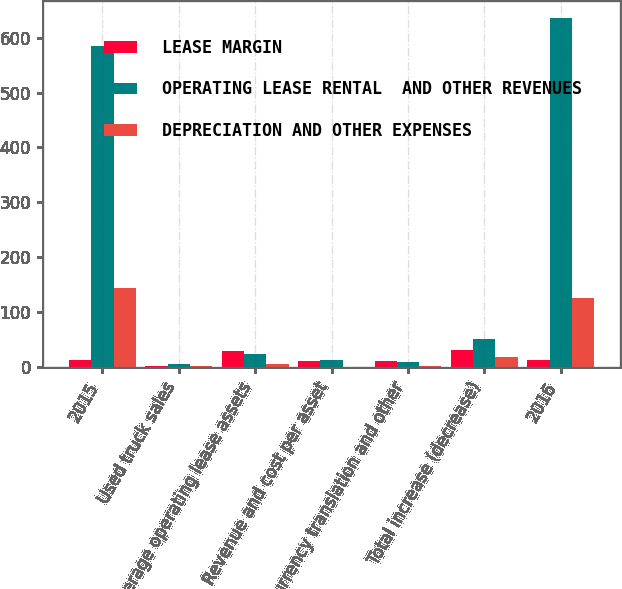Convert chart to OTSL. <chart><loc_0><loc_0><loc_500><loc_500><stacked_bar_chart><ecel><fcel>2015<fcel>Used truck sales<fcel>Average operating lease assets<fcel>Revenue and cost per asset<fcel>Currency translation and other<fcel>Total increase (decrease)<fcel>2016<nl><fcel>LEASE MARGIN<fcel>12.5<fcel>3.2<fcel>29.2<fcel>11.8<fcel>12.2<fcel>32<fcel>12.5<nl><fcel>OPERATING LEASE RENTAL  AND OTHER REVENUES<fcel>583.7<fcel>5.2<fcel>24<fcel>12.5<fcel>9.4<fcel>51.5<fcel>635.2<nl><fcel>DEPRECIATION AND OTHER EXPENSES<fcel>144.8<fcel>2<fcel>5.2<fcel>0.7<fcel>2.8<fcel>19.5<fcel>125.3<nl></chart> 